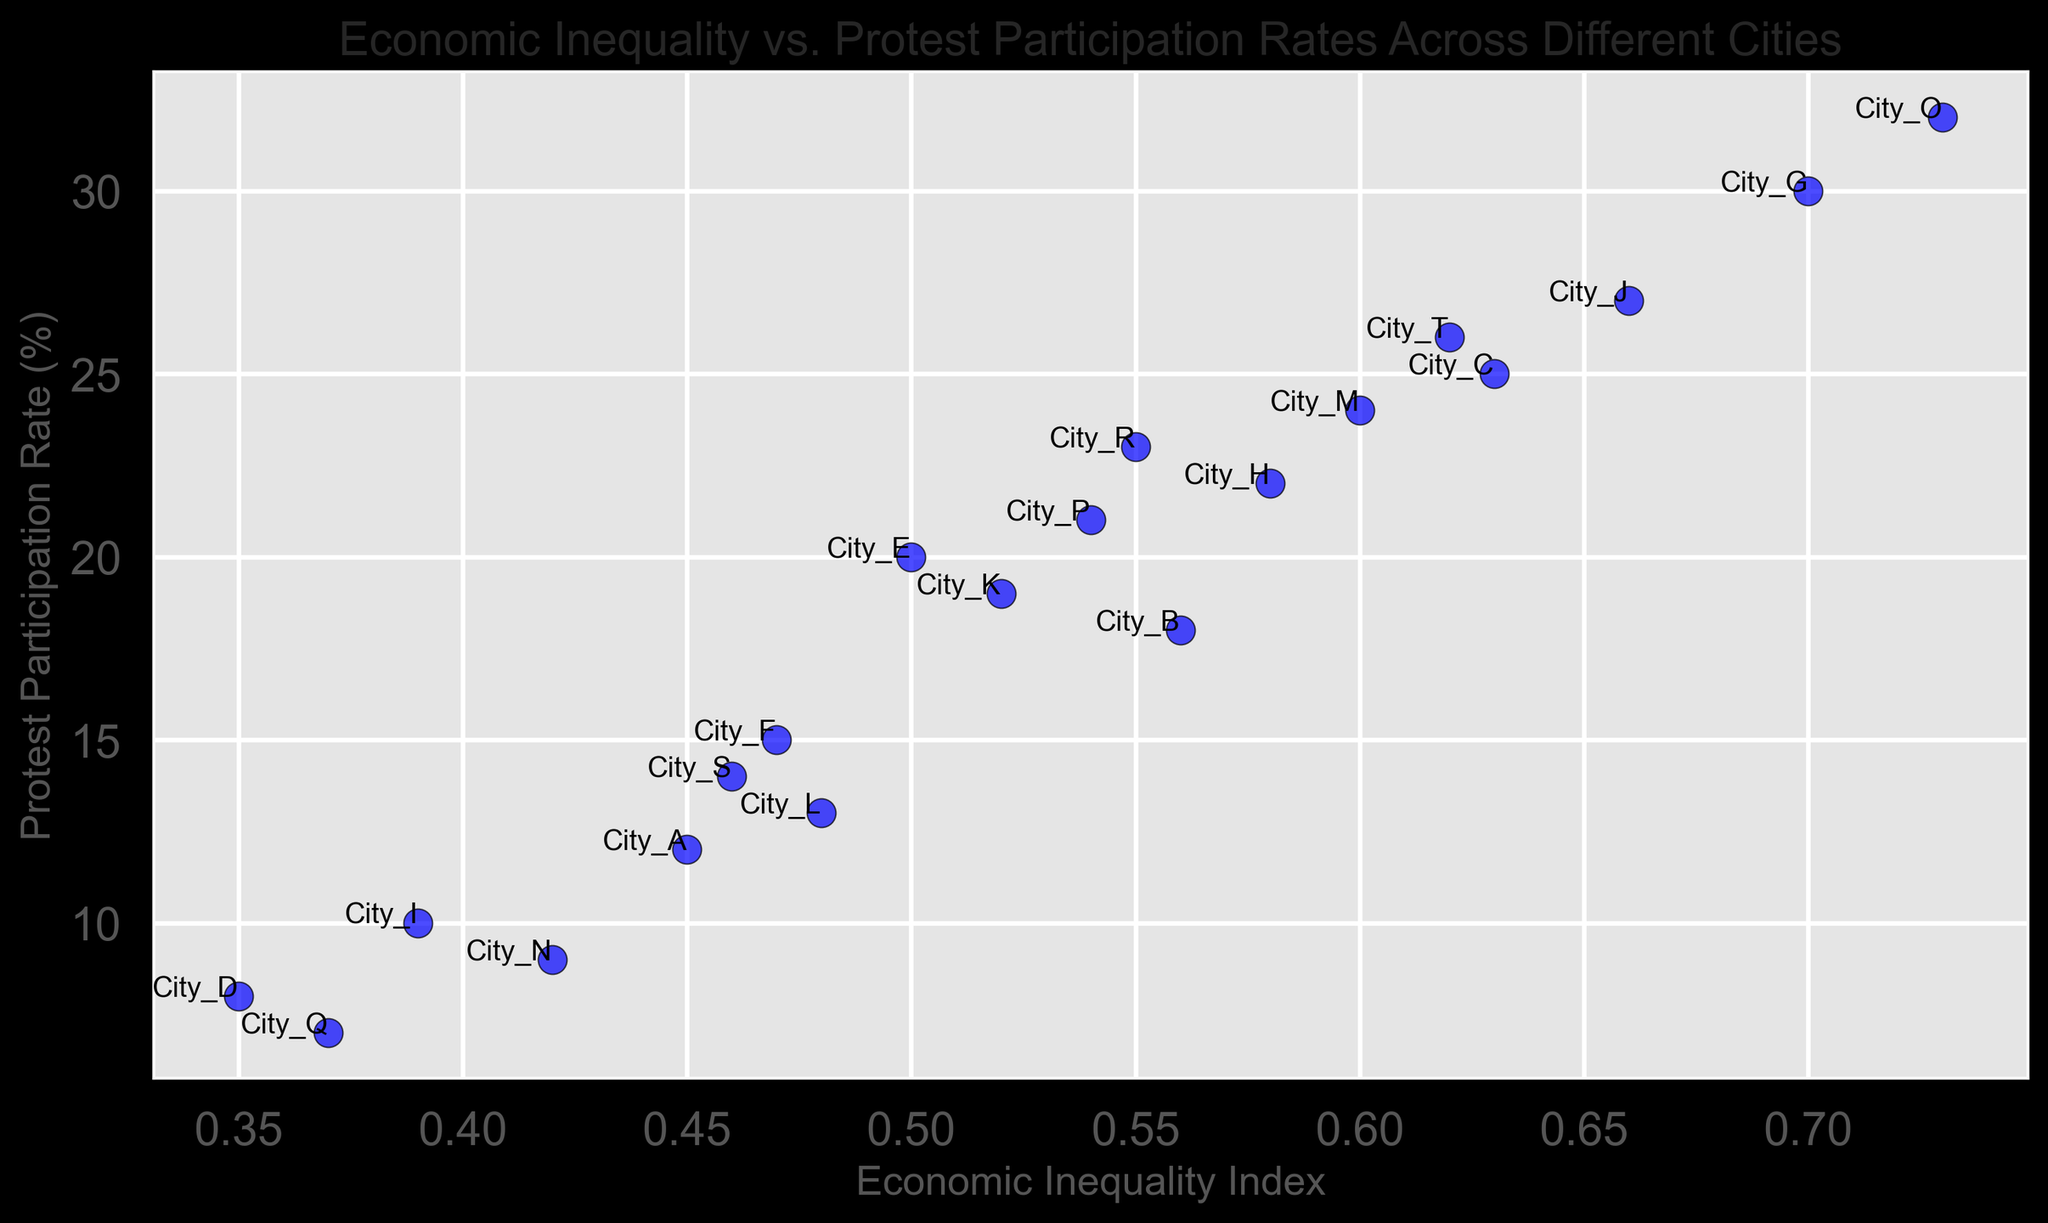Which city has the highest protest participation rate? We look at the scatter plot for the point with the highest y-value (Protest Participation Rate). The city corresponding to this point is City_O.
Answer: City_O How does the protest participation rate of City_H compare to that of City_J? We find the y-values for both City_H and City_J from the scatter plot. City_H has a participation rate of 22%, while City_J has a rate of 27%. Comparing the two, City_H has a lower rate than City_J.
Answer: City_H has a lower rate than City_J Which city has the lowest economic inequality index? We look at the x-values on the scatter plot for the point with the smallest x-value (Economic Inequality Index). The city corresponding to this point is City_Q.
Answer: City_Q What is the average protest participation rate for cities with an economic inequality index greater than 0.50? First, identify the points with x-values greater than 0.50: City_B (18%), City_E (20%), City_G (30%), City_H (22%), City_J (27%), City_K (19%), City_M (24%), City_O (32%), City_P (21%), City_R (23%), City_T (26%). The sum of these rates is 262%. There are 11 cities, so the average rate is 262/11 = 23.82%.
Answer: 23.82% What is the difference in protest participation rates between the cities with the highest and lowest economic inequality indexes? Identify the cities with the highest and lowest x-values. The highest is City_O with a rate of 32%, and the lowest is City_Q with a rate of 7%. The difference is 32% - 7% = 25%.
Answer: 25% Which city has an economic inequality index closest to 0.5, and what is its protest participation rate? Identify the city with an x-value closest to 0.5, which is City_E with an index of 0.50. The corresponding y-value (protest participation rate) for City_E is 20%.
Answer: City_E, 20% Does a higher economic inequality index generally correlate with a higher protest participation rate? Visually, most points with higher x-values (economic inequality index) seem to have higher y-values (protest participation rates). This suggests a positive correlation.
Answer: Yes, generally What is the median protest participation rate among all the cities? List all protest participation rates: [12, 18, 25, 8, 20, 15, 30, 22, 10, 27, 19, 13, 24, 9, 32, 21, 7, 23, 14, 26]. When sorted, the median is the average of the 10th and 11th values (18 and 19), so the median is (18+19)/2 = 18.5%.
Answer: 18.5% 